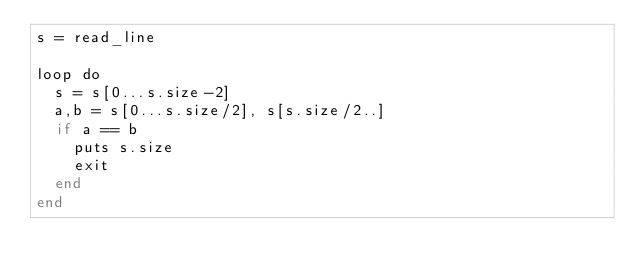Convert code to text. <code><loc_0><loc_0><loc_500><loc_500><_Crystal_>s = read_line

loop do
  s = s[0...s.size-2]
  a,b = s[0...s.size/2], s[s.size/2..]
  if a == b
    puts s.size
    exit
  end
end
</code> 